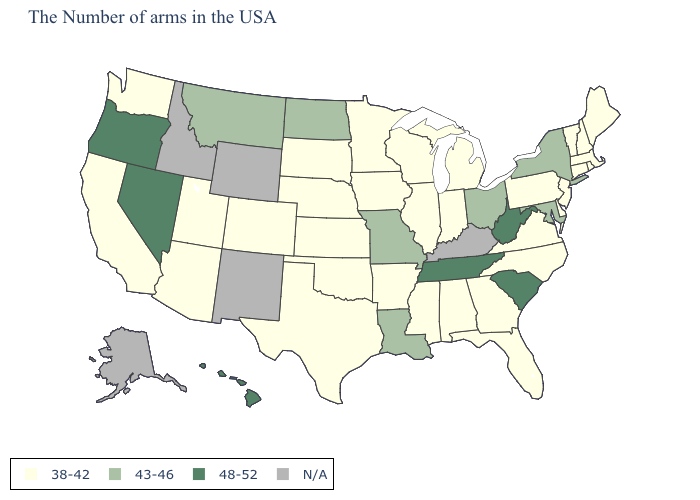What is the value of Oklahoma?
Short answer required. 38-42. Name the states that have a value in the range 43-46?
Write a very short answer. New York, Maryland, Ohio, Louisiana, Missouri, North Dakota, Montana. What is the value of Massachusetts?
Quick response, please. 38-42. What is the highest value in the MidWest ?
Be succinct. 43-46. What is the value of Illinois?
Give a very brief answer. 38-42. What is the value of Michigan?
Answer briefly. 38-42. Name the states that have a value in the range 48-52?
Answer briefly. South Carolina, West Virginia, Tennessee, Nevada, Oregon, Hawaii. Does Virginia have the lowest value in the USA?
Be succinct. Yes. What is the value of Colorado?
Quick response, please. 38-42. Name the states that have a value in the range 38-42?
Concise answer only. Maine, Massachusetts, Rhode Island, New Hampshire, Vermont, Connecticut, New Jersey, Delaware, Pennsylvania, Virginia, North Carolina, Florida, Georgia, Michigan, Indiana, Alabama, Wisconsin, Illinois, Mississippi, Arkansas, Minnesota, Iowa, Kansas, Nebraska, Oklahoma, Texas, South Dakota, Colorado, Utah, Arizona, California, Washington. What is the value of Idaho?
Answer briefly. N/A. Does the map have missing data?
Write a very short answer. Yes. What is the highest value in the USA?
Be succinct. 48-52. Does Missouri have the highest value in the MidWest?
Give a very brief answer. Yes. 